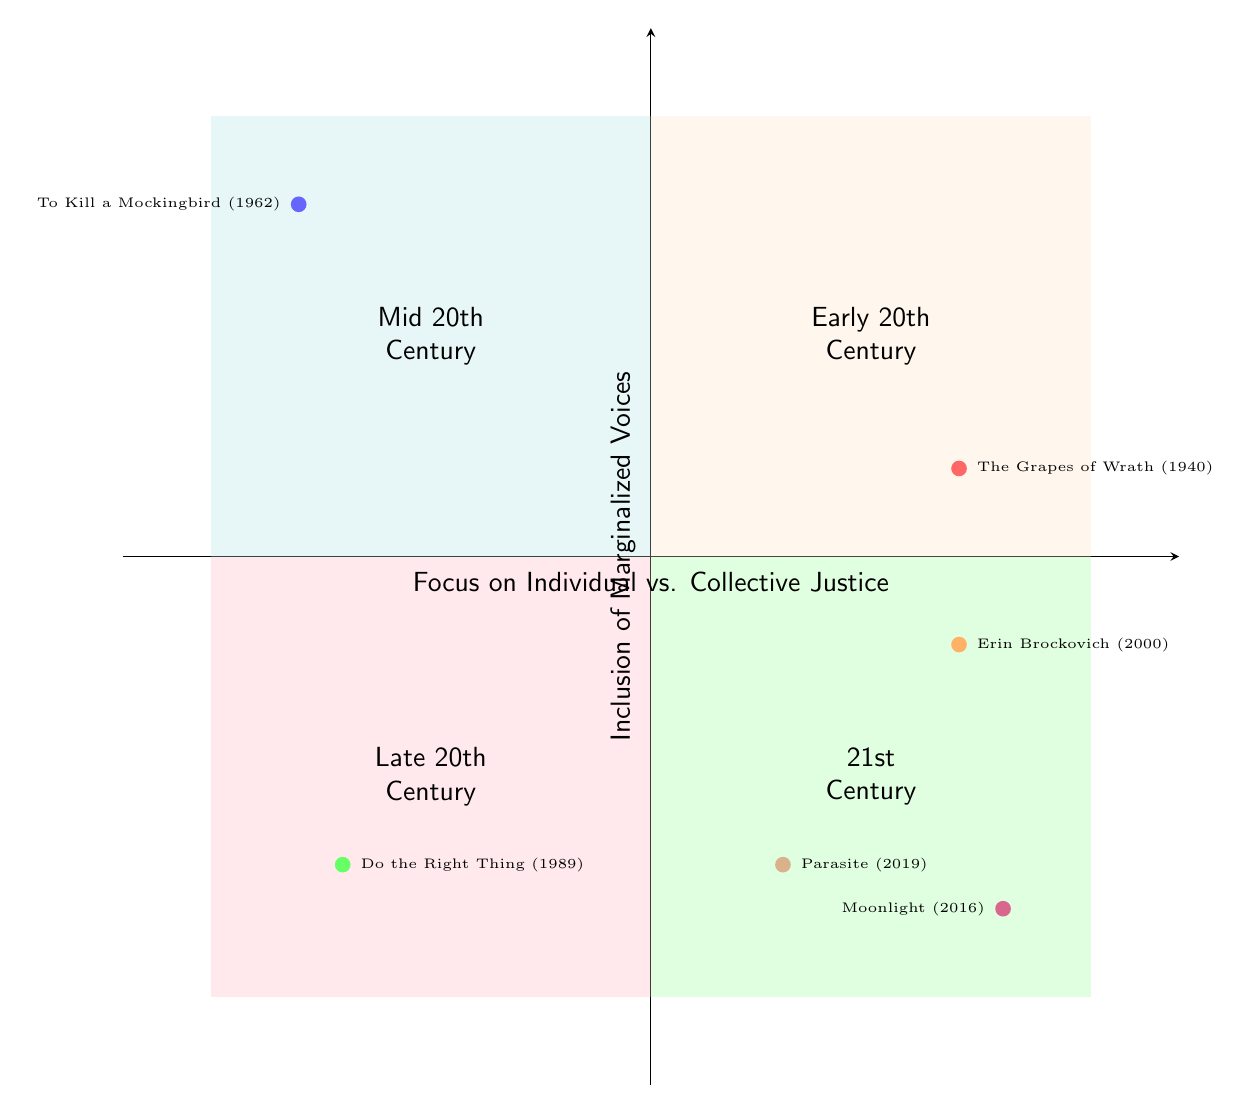What film is located in Quadrant I? In Quadrant I, we can see the node for "The Grapes of Wrath (1940)", which is positioned there according to the data provided.
Answer: The Grapes of Wrath (1940) How many films are in Quadrant IV? By counting the data points listed for Quadrant IV, I identify three films ("Erin Brockovich (2000)", "Moonlight (2016)", and "Parasite (2019)").
Answer: 3 Which film has a high inclusion of marginalized voices and focuses on collective justice? In Quadrant III, "Do the Right Thing (1989)" has a high inclusion of marginalized voices indicated by its vertical positioning, while also focusing on collective justice, as shown by its horizontal position.
Answer: Do the Right Thing (1989) What is the context of "Moonlight (2016)"? The context for "Moonlight (2016)" describes how it explores the complexities of African-American identity and sexual orientation through intimate storytelling. This insight supports its placement in Quadrant IV with high verticality for marginalized voices.
Answer: Explores the complexities of African-American identity and sexual orientation through intimate storytelling Which film is positioned in Quadrant II and which theme does it focus on? "To Kill a Mockingbird (1962)" is in Quadrant II, and it focuses on individual justice, as indicated by its horizontal position while also having a high inclusion of marginalized voices.
Answer: To Kill a Mockingbird (1962), Individual Justice What trend in film themes can be seen from the early to the late 20th century regarding social justice? Analyzing the quadrants, films in the early and late 20th century show a shift from a collective focus in "The Grapes of Wrath (1940)" to a more individual focus seen in "To Kill a Mockingbird (1962)" and "Do the Right Thing (1989)", illustrating evolving themes in social justice narratives.
Answer: Shift from collective to individual focus Which quadrant depicts films that primarily address collective justice themes in the 21st century? Quadrant IV features "Parasite (2019)", a film that examines class disparities and social stratification, showcasing an ongoing focus on collective justice themes in the 21st century.
Answer: Quadrant IV How does "Erin Brockovich (2000)" represent individual justice? "Erin Brockovich (2000)" is centered on one woman's personal fight against corporate pollution, thus illustrating a strong individual justice theme, which is evident from its horizontal position in Quadrant IV.
Answer: Centers on one woman's fight against a corporation 